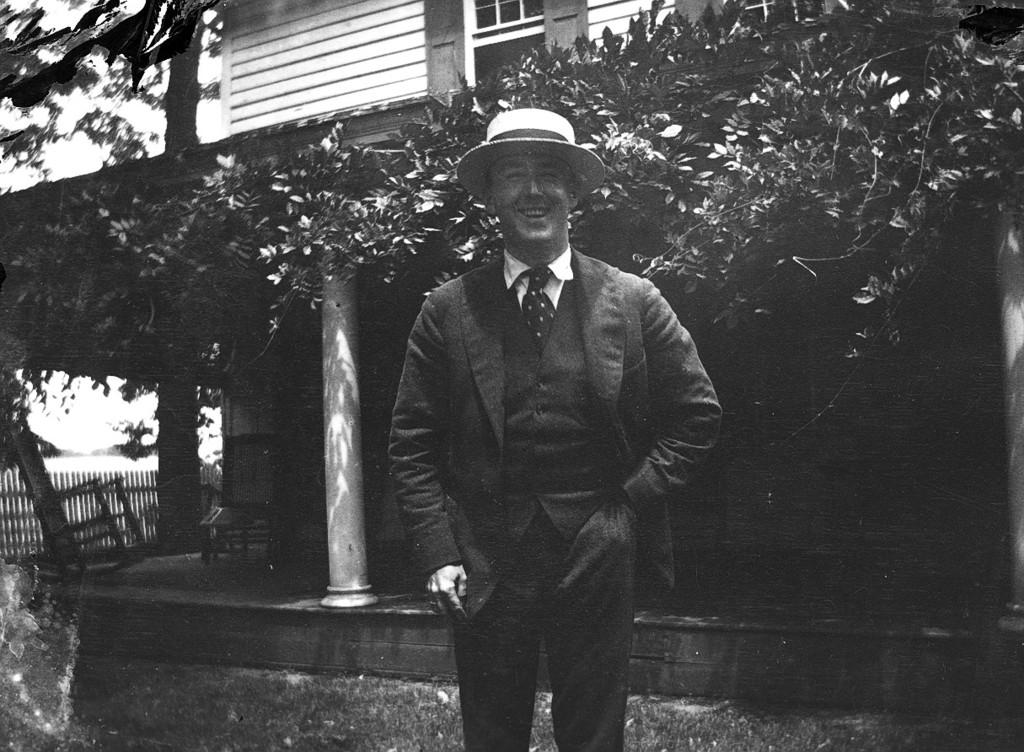What type of natural elements can be seen in the image? There are trees in the image. What type of man-made structure is visible in the image? There is a building in the image. What architectural features can be seen in the building? There are windows in the image. What type of furniture is present in the image? There are chairs in the image. What type of vertical structure is present in the image? There is a pole in the image. What type of barrier is present in the image? There is fencing in the image. Is there a person present in the image? Yes, there is a person standing in the image. What is the color scheme of the image? The image is in black and white. What type of pets can be seen playing with a riddle in the image? There are no pets or riddles present in the image. What type of industrial equipment can be seen in the image? There is no industrial equipment present in the image. 